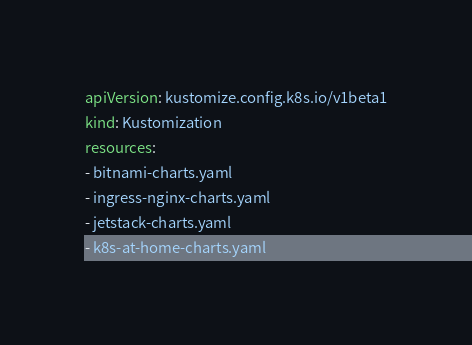Convert code to text. <code><loc_0><loc_0><loc_500><loc_500><_YAML_>apiVersion: kustomize.config.k8s.io/v1beta1
kind: Kustomization
resources:
- bitnami-charts.yaml
- ingress-nginx-charts.yaml
- jetstack-charts.yaml
- k8s-at-home-charts.yaml
</code> 